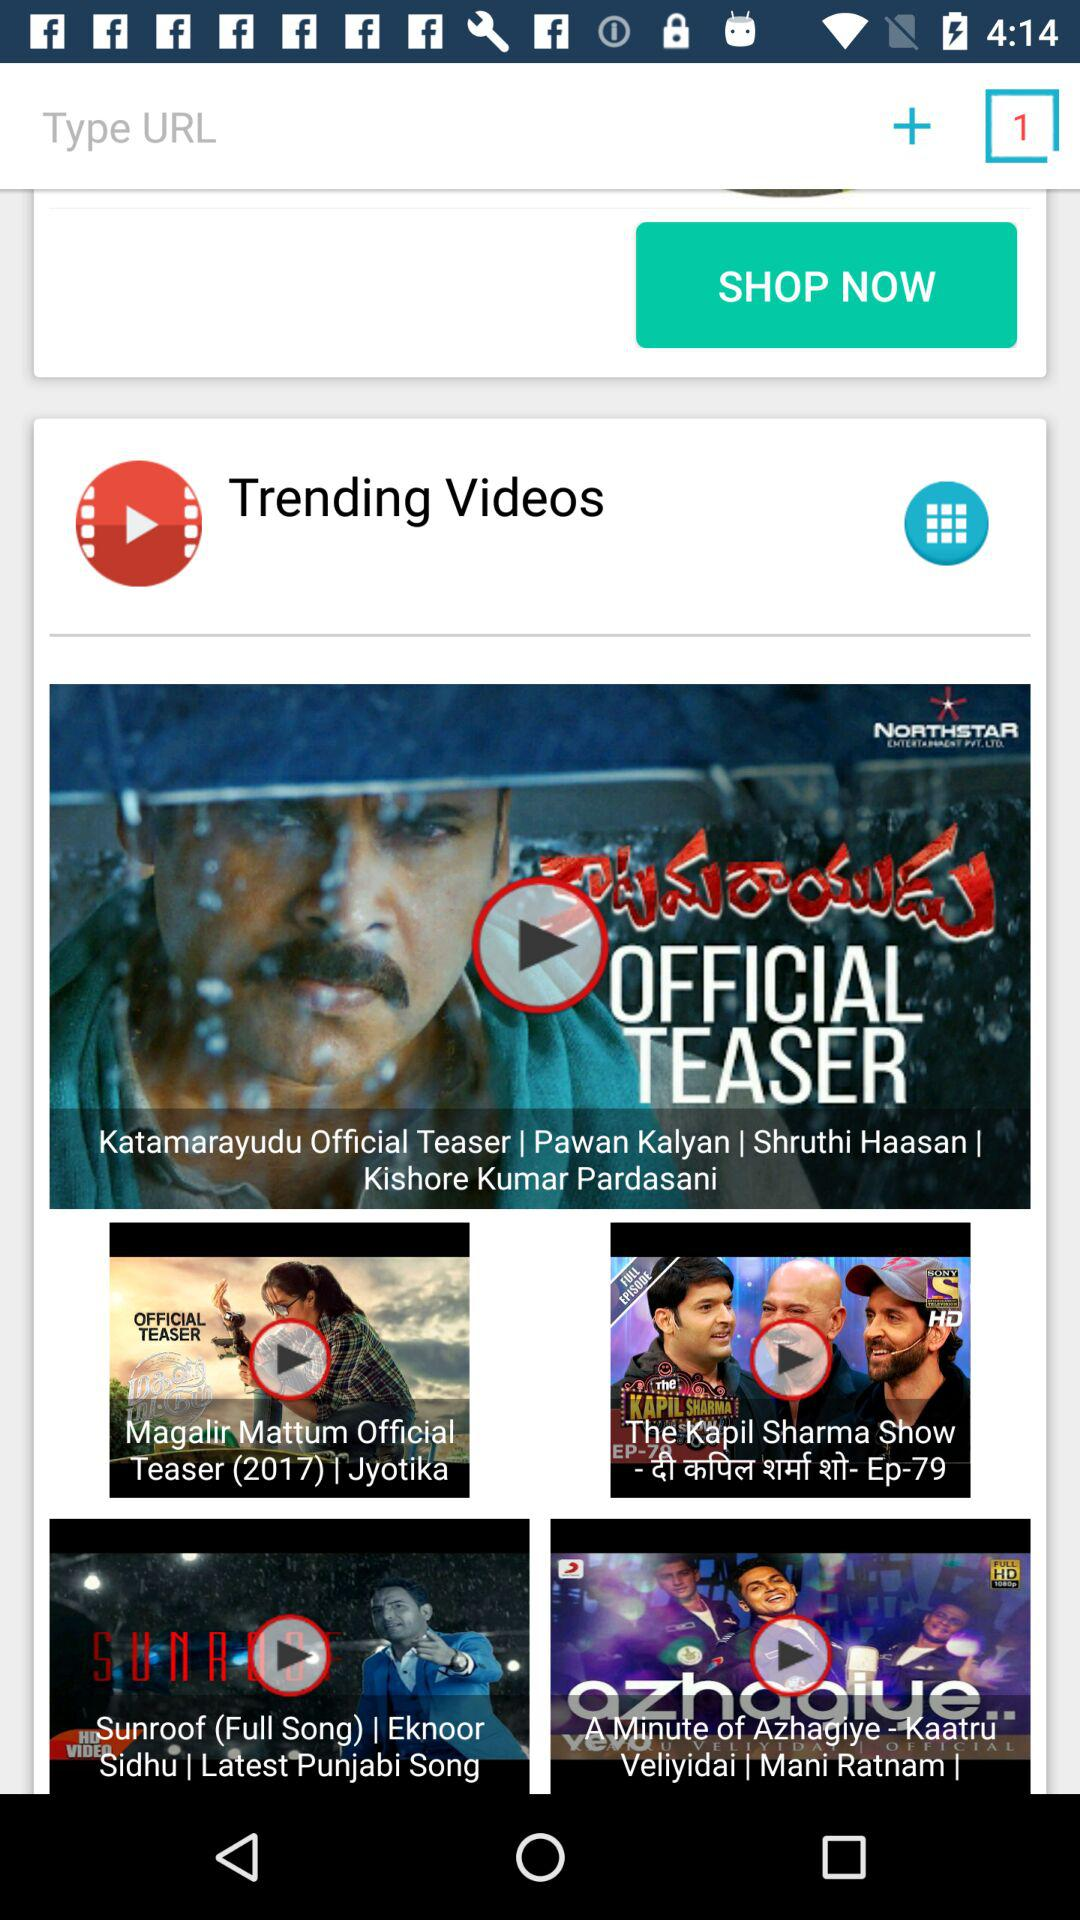What is the name of application?
When the provided information is insufficient, respond with <no answer>. <no answer> 